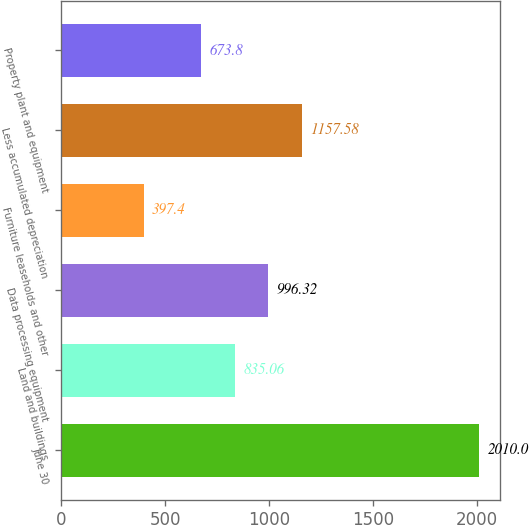<chart> <loc_0><loc_0><loc_500><loc_500><bar_chart><fcel>June 30<fcel>Land and buildings<fcel>Data processing equipment<fcel>Furniture leaseholds and other<fcel>Less accumulated depreciation<fcel>Property plant and equipment<nl><fcel>2010<fcel>835.06<fcel>996.32<fcel>397.4<fcel>1157.58<fcel>673.8<nl></chart> 